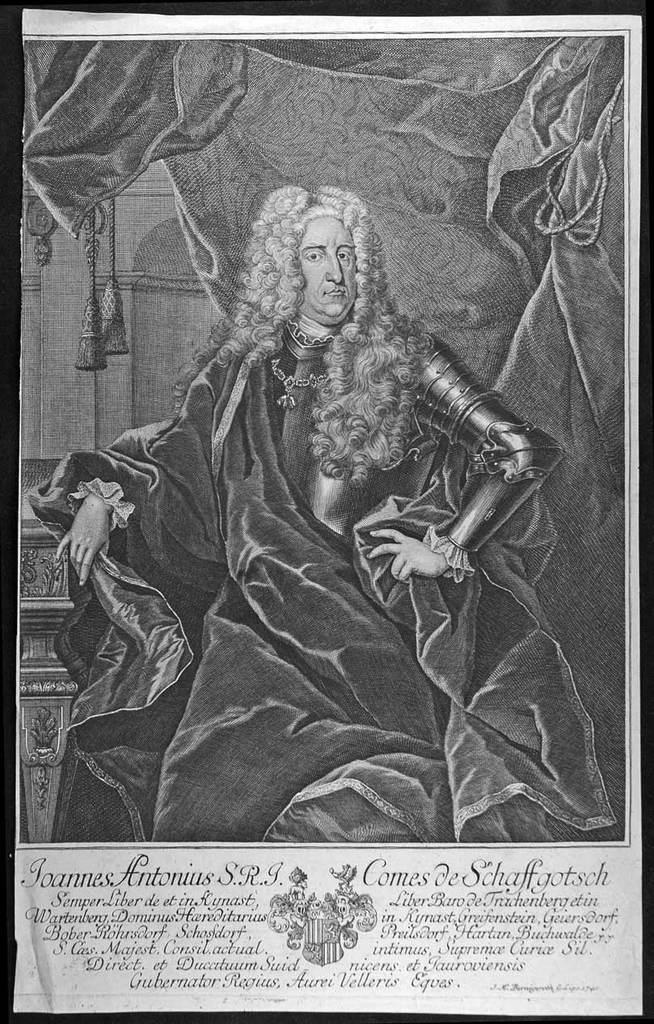What type of visual is the image? The image is a poster. What is the main subject of the poster? There is a person sitting in the poster. What else can be seen in the poster besides the person? There are clothes depicted in the poster. Is there any text present in the poster? Yes, there is text present in the poster. How does the fog affect the person's visibility in the poster? There is no fog present in the poster, so it does not affect the person's visibility. 